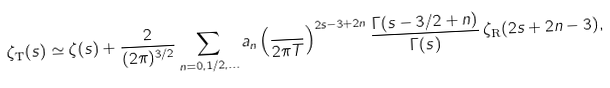<formula> <loc_0><loc_0><loc_500><loc_500>\zeta _ { \text  T}(s)\simeq\zeta(s)+\frac{2}{(2\pi)^{3/2} } \sum _ { n = 0 , 1 / 2 , \dots } a _ { n } \left ( \frac { } { 2 \pi T } \right ) ^ { 2 s - 3 + 2 n } \frac { \Gamma ( s - 3 / 2 + n ) } { \Gamma ( s ) } \, \zeta _ { \text {R} } ( 2 s + 2 n - 3 ) ,</formula> 